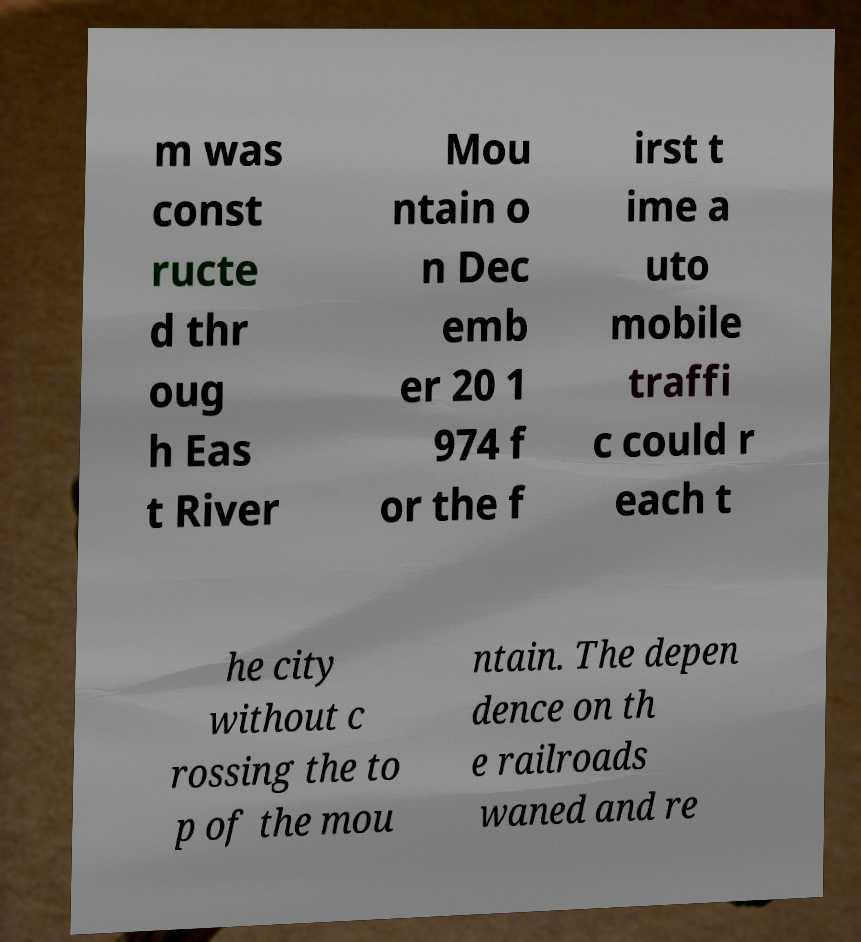Can you accurately transcribe the text from the provided image for me? m was const ructe d thr oug h Eas t River Mou ntain o n Dec emb er 20 1 974 f or the f irst t ime a uto mobile traffi c could r each t he city without c rossing the to p of the mou ntain. The depen dence on th e railroads waned and re 